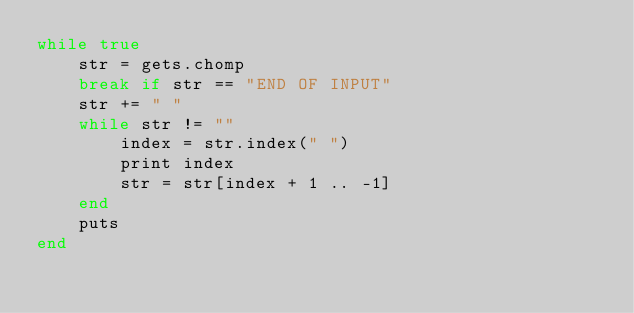<code> <loc_0><loc_0><loc_500><loc_500><_Ruby_>while true
    str = gets.chomp 
    break if str == "END OF INPUT"
    str += " "
    while str != ""
        index = str.index(" ")
        print index
        str = str[index + 1 .. -1]
    end
    puts
end
</code> 